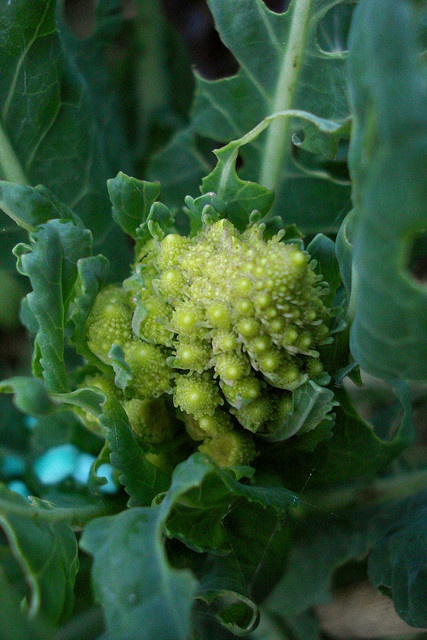Describe the objects in this image and their specific colors. I can see a broccoli in darkgreen, olive, and black tones in this image. 